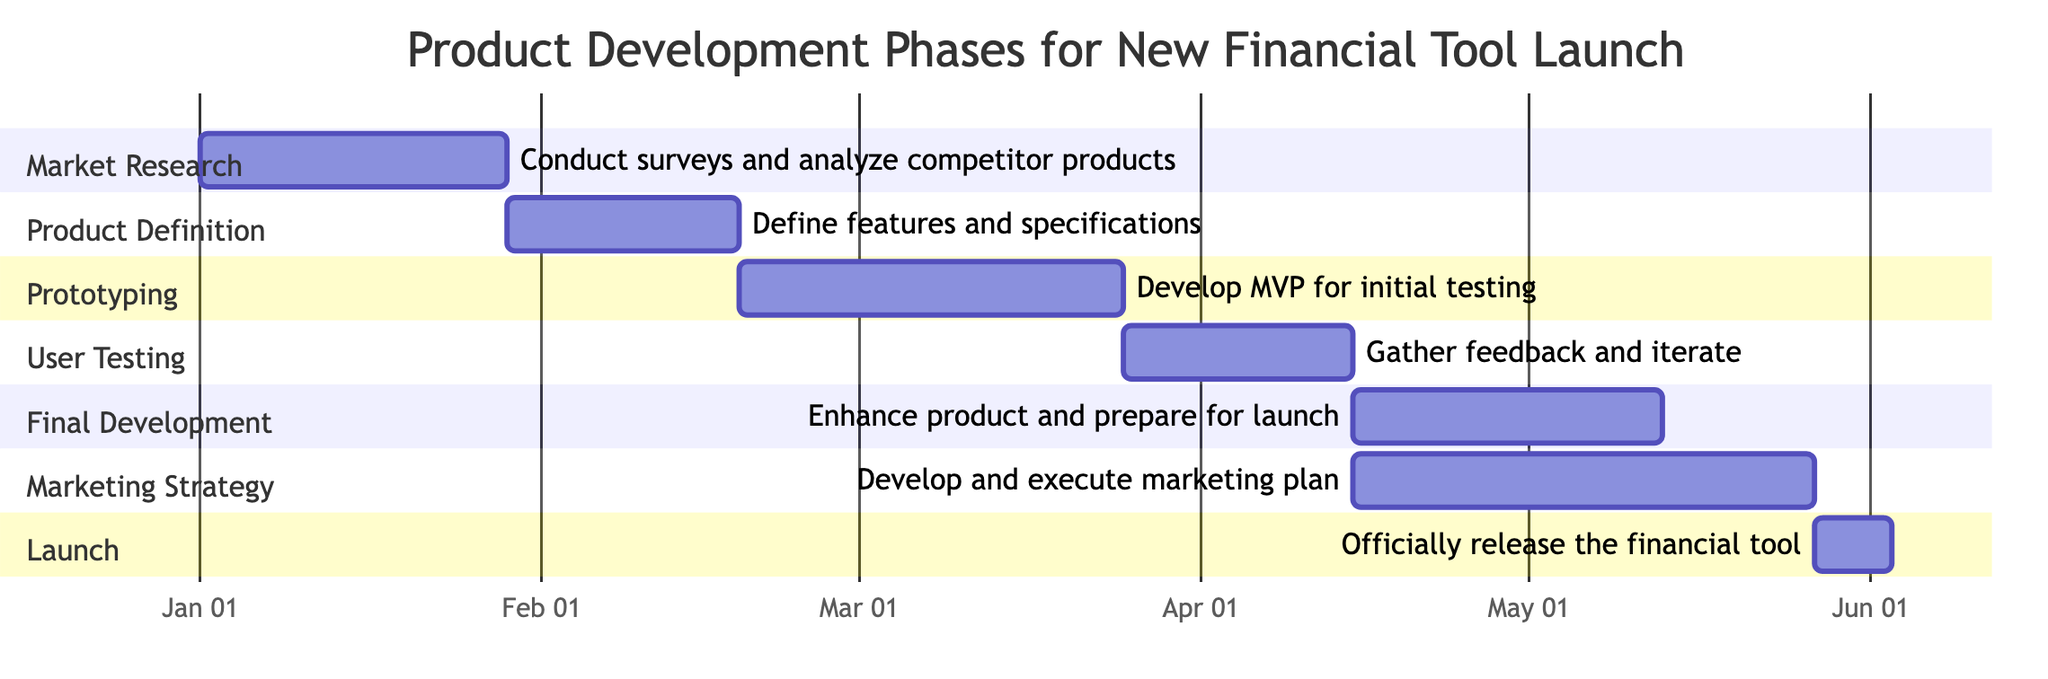What is the total number of phases in the product development process? The diagram outlines seven distinct phases: Market Research, Product Definition, Prototyping, User Testing, Final Development, Marketing Strategy, and Launch. Counting each of these phases totals to seven.
Answer: 7 Which phase has the longest duration? By comparing the durations of each phase, Marketing Strategy has a duration of six weeks, which is longer than all other phases.
Answer: Marketing Strategy When does the User Testing phase start? The diagram specifies that the User Testing phase begins on March 25, 2024, as indicated under this section of the Gantt chart.
Answer: March 25, 2024 What two phases overlap in their timelines? The Final Development phase and the Marketing Strategy phase both start on April 15, 2024, and therefore overlap during those dates.
Answer: Final Development and Marketing Strategy How many weeks is the Prototyping phase? The Prototyping phase is clearly marked in the diagram as having a duration of five weeks, directly noted beside that phase.
Answer: 5 weeks Which phase occurs right before the Launch phase? Analyzing the timeline, it can be determined that the phase that takes place immediately before the Launch phase is the Final Development phase, which ends on May 12, 2024.
Answer: Final Development What is the end date of the Product Definition phase? According to the section titled Product Definition, the end date for that phase is February 18, 2024, as shown in the diagram.
Answer: February 18, 2024 How much time elapses from Market Research to Launch? The Market Research phase ends on January 28, 2024, while the Launch phase starts on May 27, 2024. Calculating the weeks in between gives us a difference of 16 weeks.
Answer: 16 weeks 